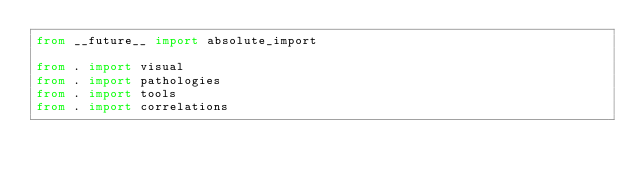Convert code to text. <code><loc_0><loc_0><loc_500><loc_500><_Python_>from __future__ import absolute_import

from . import visual
from . import pathologies
from . import tools
from . import correlations
</code> 